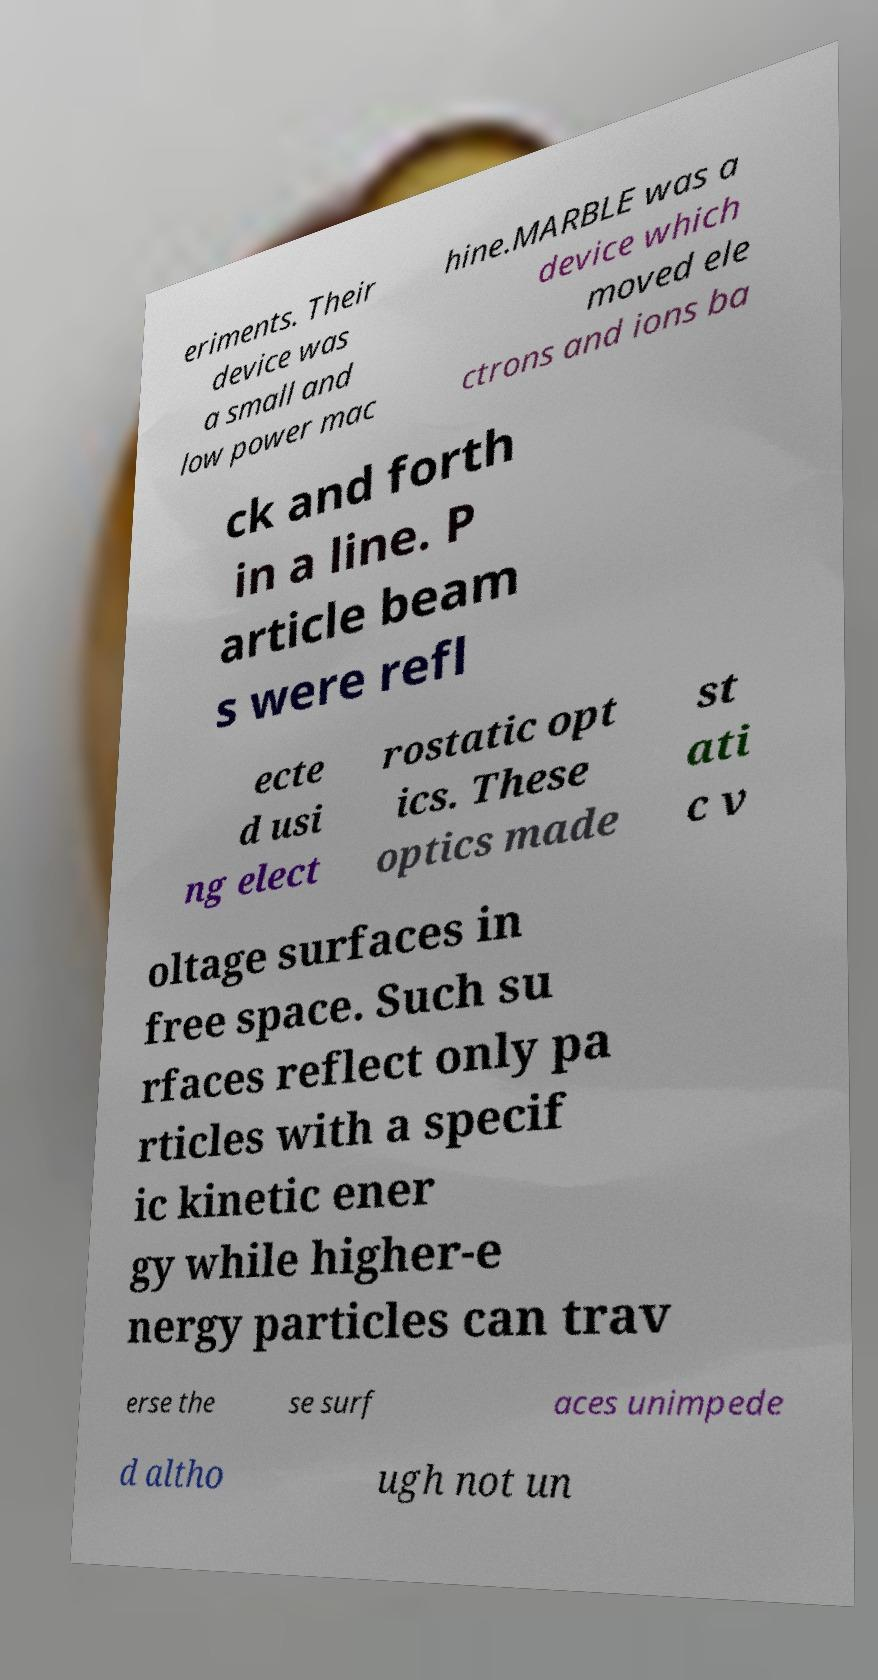Could you assist in decoding the text presented in this image and type it out clearly? eriments. Their device was a small and low power mac hine.MARBLE was a device which moved ele ctrons and ions ba ck and forth in a line. P article beam s were refl ecte d usi ng elect rostatic opt ics. These optics made st ati c v oltage surfaces in free space. Such su rfaces reflect only pa rticles with a specif ic kinetic ener gy while higher-e nergy particles can trav erse the se surf aces unimpede d altho ugh not un 